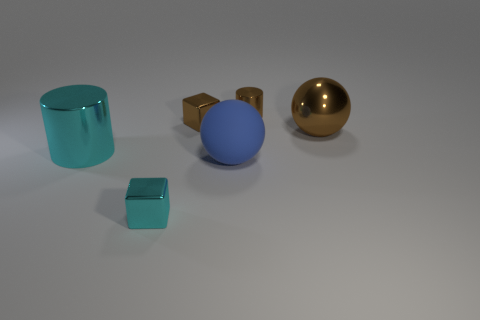Add 1 blue rubber cubes. How many objects exist? 7 Subtract 1 blocks. How many blocks are left? 1 Subtract all gray blocks. Subtract all red cylinders. How many blocks are left? 2 Subtract all blue cubes. How many purple balls are left? 0 Subtract all metallic cubes. Subtract all big rubber balls. How many objects are left? 3 Add 2 tiny cyan blocks. How many tiny cyan blocks are left? 3 Add 3 matte things. How many matte things exist? 4 Subtract 1 brown cubes. How many objects are left? 5 